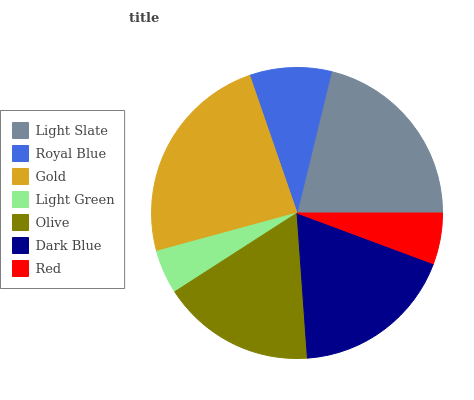Is Light Green the minimum?
Answer yes or no. Yes. Is Gold the maximum?
Answer yes or no. Yes. Is Royal Blue the minimum?
Answer yes or no. No. Is Royal Blue the maximum?
Answer yes or no. No. Is Light Slate greater than Royal Blue?
Answer yes or no. Yes. Is Royal Blue less than Light Slate?
Answer yes or no. Yes. Is Royal Blue greater than Light Slate?
Answer yes or no. No. Is Light Slate less than Royal Blue?
Answer yes or no. No. Is Olive the high median?
Answer yes or no. Yes. Is Olive the low median?
Answer yes or no. Yes. Is Red the high median?
Answer yes or no. No. Is Dark Blue the low median?
Answer yes or no. No. 